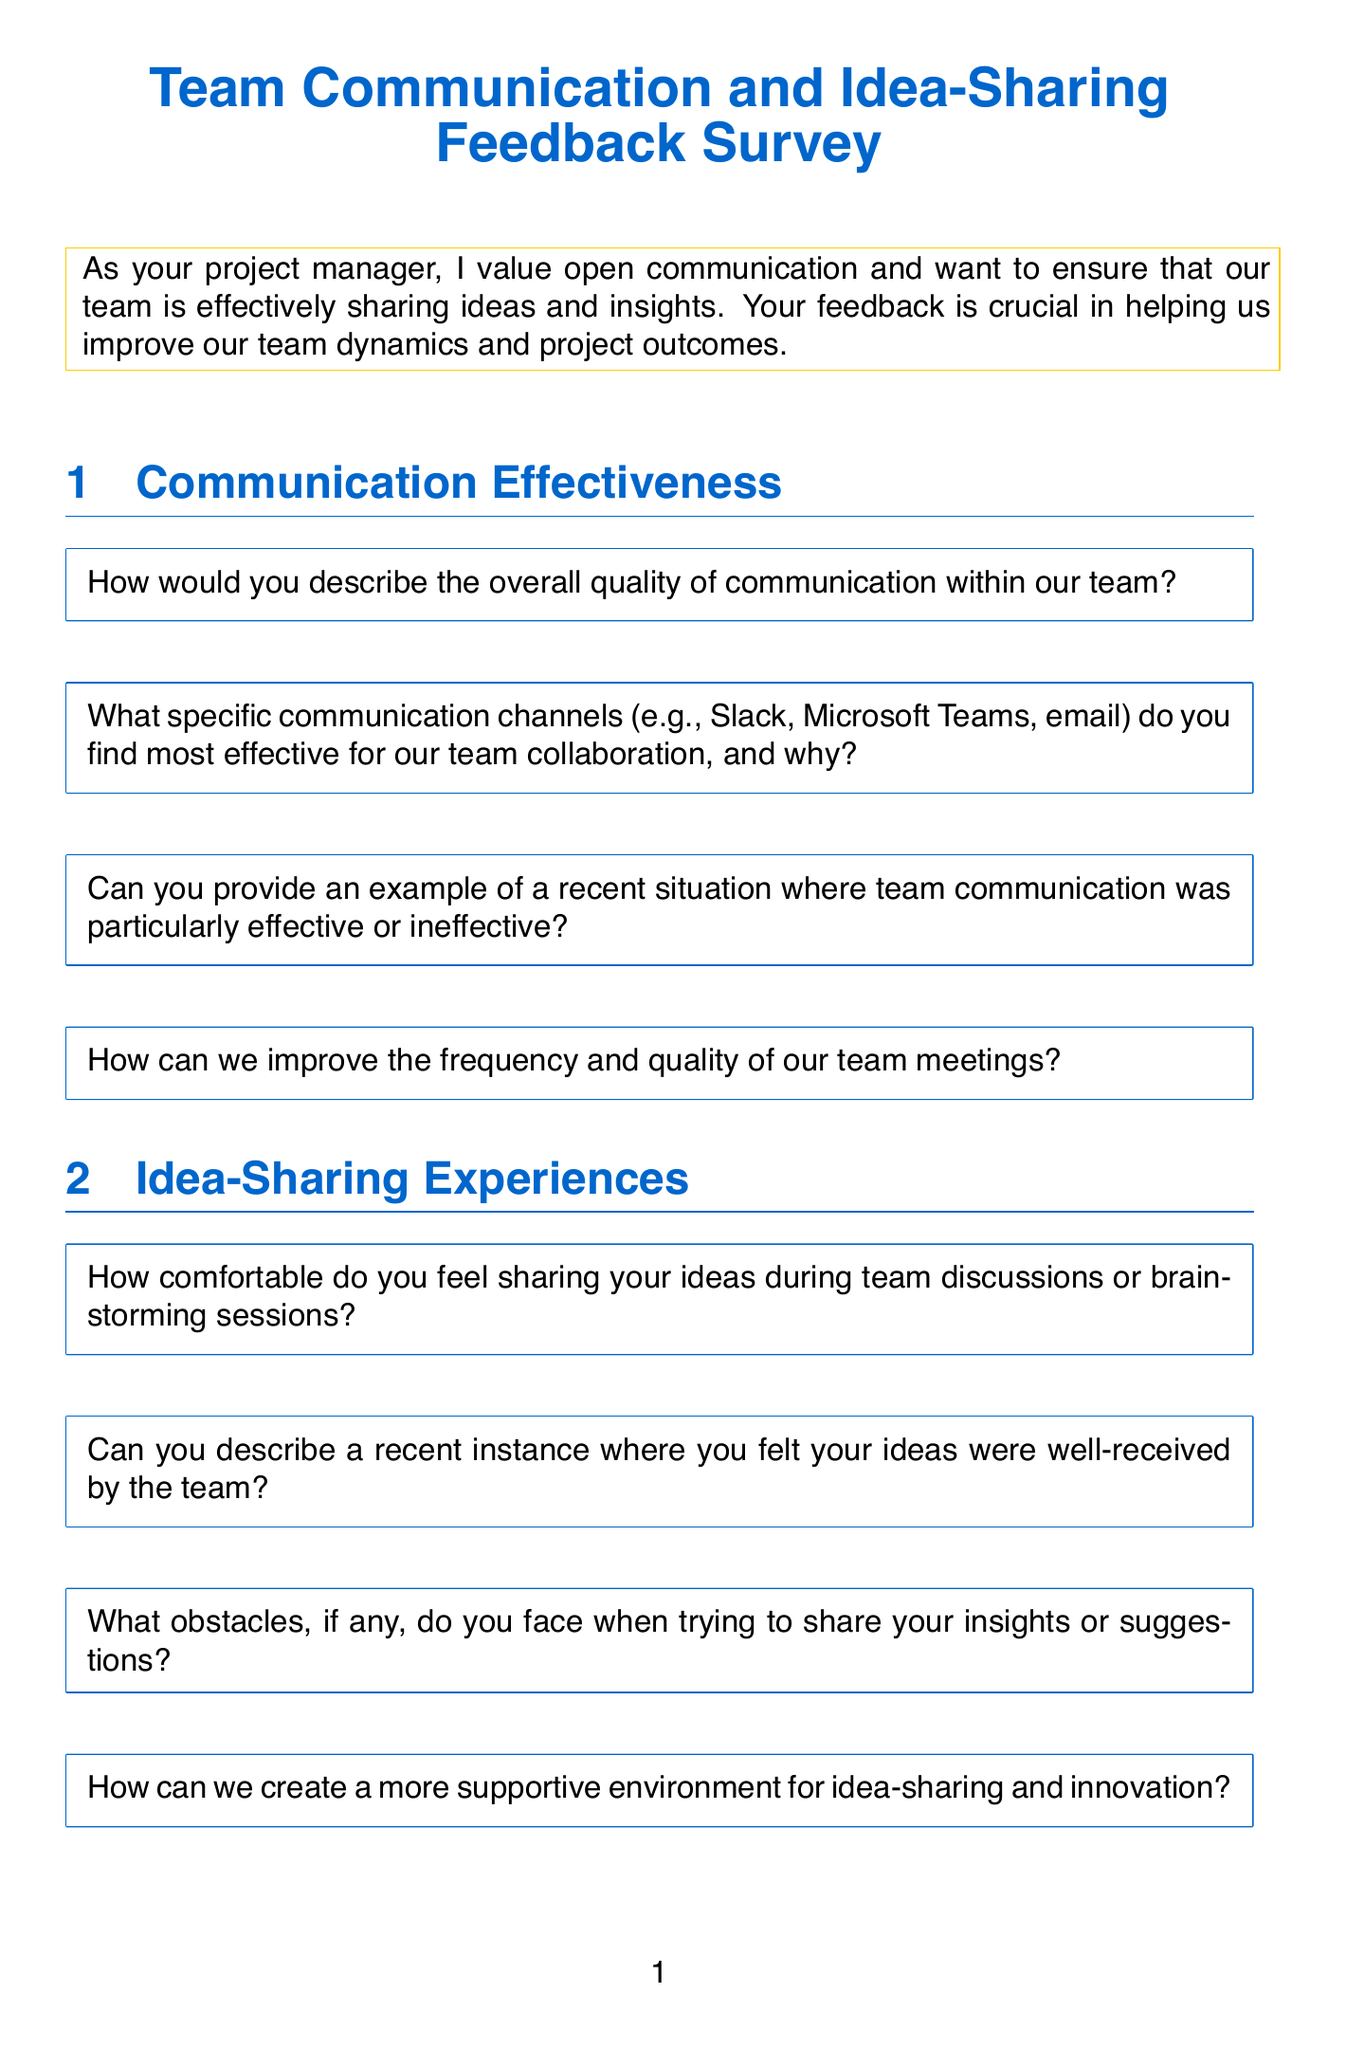What is the title of the survey? The title is found at the top of the document, summarizing the purpose of the survey.
Answer: Team Communication and Idea-Sharing Feedback Survey How many sections are in the survey? The document lists the different sections of the survey for feedback.
Answer: Five What is the first question in the Communication Effectiveness section? The first question is found in the Communication Effectiveness section of the survey.
Answer: How would you describe the overall quality of communication within our team? What specific project is mentioned in the Project-Specific Communication section? The project is referenced in the context of current communication assessment.
Answer: Acme Corporation software upgrade What type of format is used for the questions in this survey? The survey structure is described by the types of questions presented in each section.
Answer: Open-ended questions What is the final statement at the end of the survey? The closing text summarizes the gratitude and encourages further communication.
Answer: Thank you for taking the time to provide your valuable feedback What color is used for the section titles? The document describes the color scheme used for the headings.
Answer: Main color Which tool is mentioned as an example for project management in the survey? The example can be found in the Project-Specific Communication section regarding tools facilitating communication.
Answer: Jira 